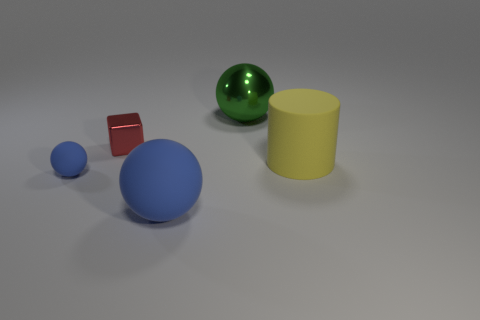The other object that is the same color as the small matte object is what shape?
Provide a short and direct response. Sphere. There is a object that is the same color as the small rubber sphere; what size is it?
Offer a terse response. Large. Is the tiny blue rubber object the same shape as the big green shiny object?
Provide a succinct answer. Yes. How many objects are big balls behind the yellow rubber object or tiny brown metallic spheres?
Ensure brevity in your answer.  1. Are there the same number of tiny matte balls right of the large yellow matte cylinder and metallic things that are behind the metallic block?
Your answer should be very brief. No. How many other things are there of the same shape as the tiny red object?
Your answer should be compact. 0. There is a yellow rubber cylinder to the right of the tiny red thing; is it the same size as the ball that is in front of the small blue ball?
Provide a succinct answer. Yes. What number of cylinders are either large objects or tiny blue matte things?
Your response must be concise. 1. How many shiny things are either tiny blocks or green spheres?
Offer a terse response. 2. There is a metallic thing that is the same shape as the small rubber object; what is its size?
Your answer should be very brief. Large. 